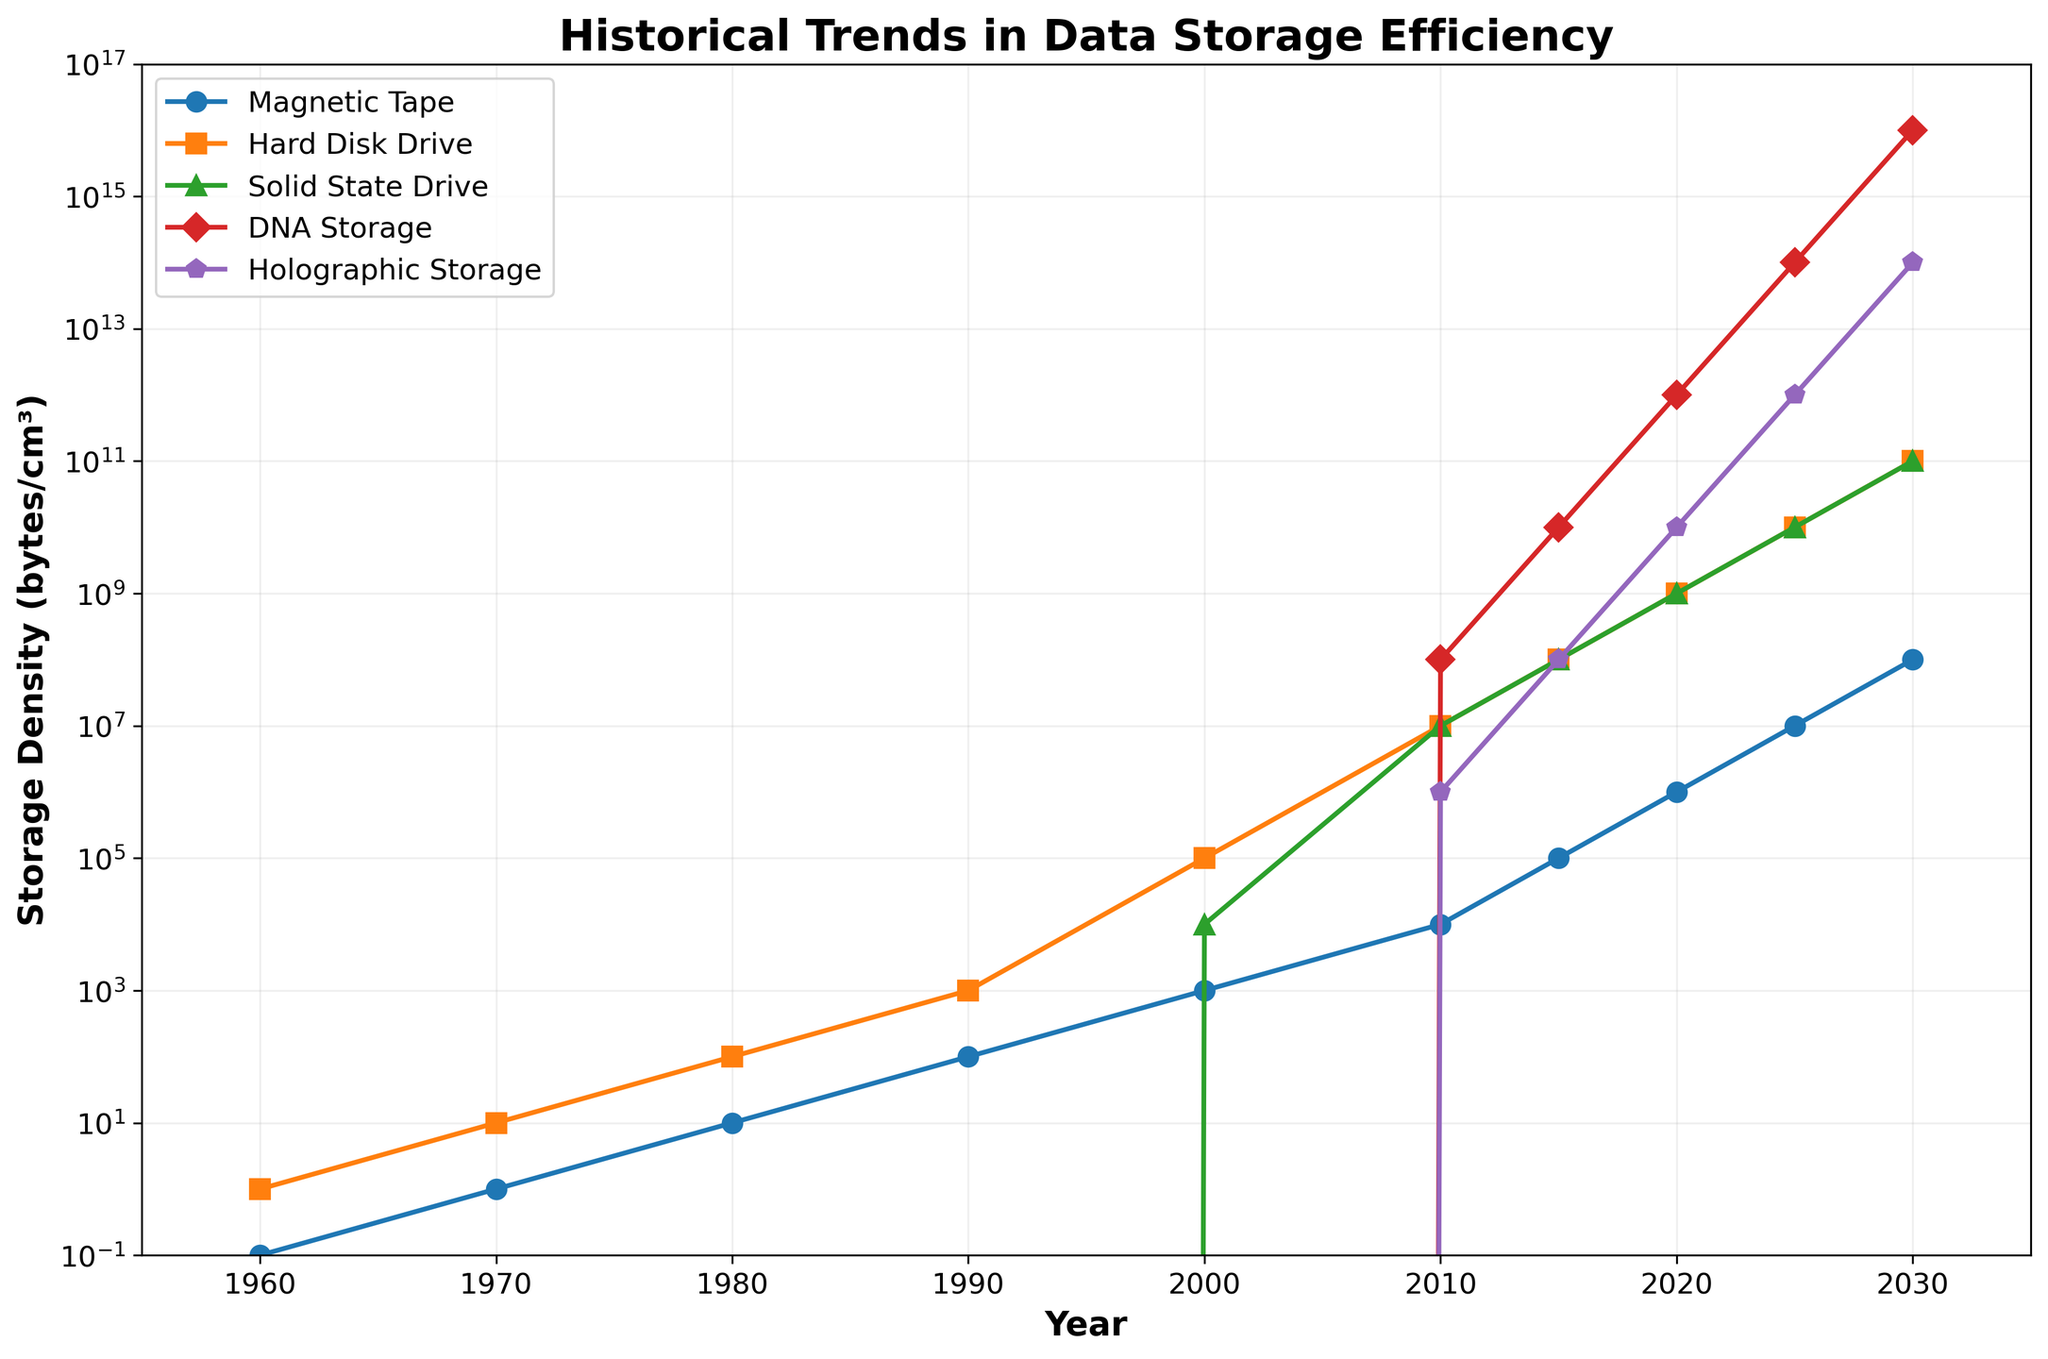When did Solid State Drive (SSD) storage first appear in the chart? SSD storage first appears in the year 2000. This is evident from the data line for SSD starting at this point on the x-axis.
Answer: 2000 Which storage technology has the highest efficiency in the year 2030? In 2030, DNA storage has the highest efficiency, indicated by its position at the top of the y-axis among all lines for this year.
Answer: DNA storage By how many orders of magnitude did Hard Disk Drive (HDD) storage efficiency improve from 1970 to 2000? In 1970, HDD efficiency was 10^1 bytes/cm³, and in 2000 it was 10^5 bytes/cm³. The improvement is 10^5 / 10^1 = 10^4, which is 4 orders of magnitude.
Answer: 4 orders of magnitude Compare the storage efficiency of Magnetic Tape and Holographic Storage in 2010. Which one was more efficient and by how much? In 2010, Magnetic Tape was 10^4 bytes/cm³ and Holographic Storage was 10^6 bytes/cm³. Holographic Storage was more efficient by a factor of 10^6 / 10^4 = 10^2 or 100 times.
Answer: Holographic Storage was more efficient by 100 times What trends can be observed in the efficiency of DNA storage from 2010 to 2030? DNA storage shows a significant upward trend, increasing from 10^8 bytes/cm³ in 2010 to 10^16 bytes/cm³ in 2030. This indicates exponential growth.
Answer: Exponential growth What is the ratio of storage efficiency between SSD and HDD in 2025? In 2025, SSD and HDD both have an efficiency of 10^10 bytes/cm³. Therefore, the ratio is 10^10 / 10^10 = 1.
Answer: 1 How does the growth rate of efficiency in Holographic Storage compare to SSD between 2015 and 2030? From 2015 to 2030, Holographic Storage grows from 10^8 to 10^14 bytes/cm³, which is a 10^14 / 10^8 = 10^6-fold increase. SSD grows from 10^8 to 10^11 bytes/cm³, which is a 10^11 / 10^8 = 10^3-fold increase. Thus, Holographic Storage grows 10^6 / 10^3 = 10^3 times faster than SSD.
Answer: Holographic Storage grows 1000 times faster What was the efficiency of Hard Disk Drives in 2010, and how does it compare to Magnetic Tape in the same year? In 2010, the efficiency of Hard Disk Drives was 10^7 bytes/cm³, while Magnetic Tape was 10^4 bytes/cm³. Hence, Hard Disk Drives were 10^7 / 10^4 = 10^3 or 1000 times more efficient than Magnetic Tape.
Answer: Hard Disk Drives were 1000 times more efficient Between which years did the efficiency of Magnetic Tape increase the most rapidly? The most rapid increase in Magnetic Tape efficiency occurs between 2000 and 2010, where it jumps from 10^3 to 10^4 bytes/cm³, an increase by a factor of 10.
Answer: 2000 and 2010 